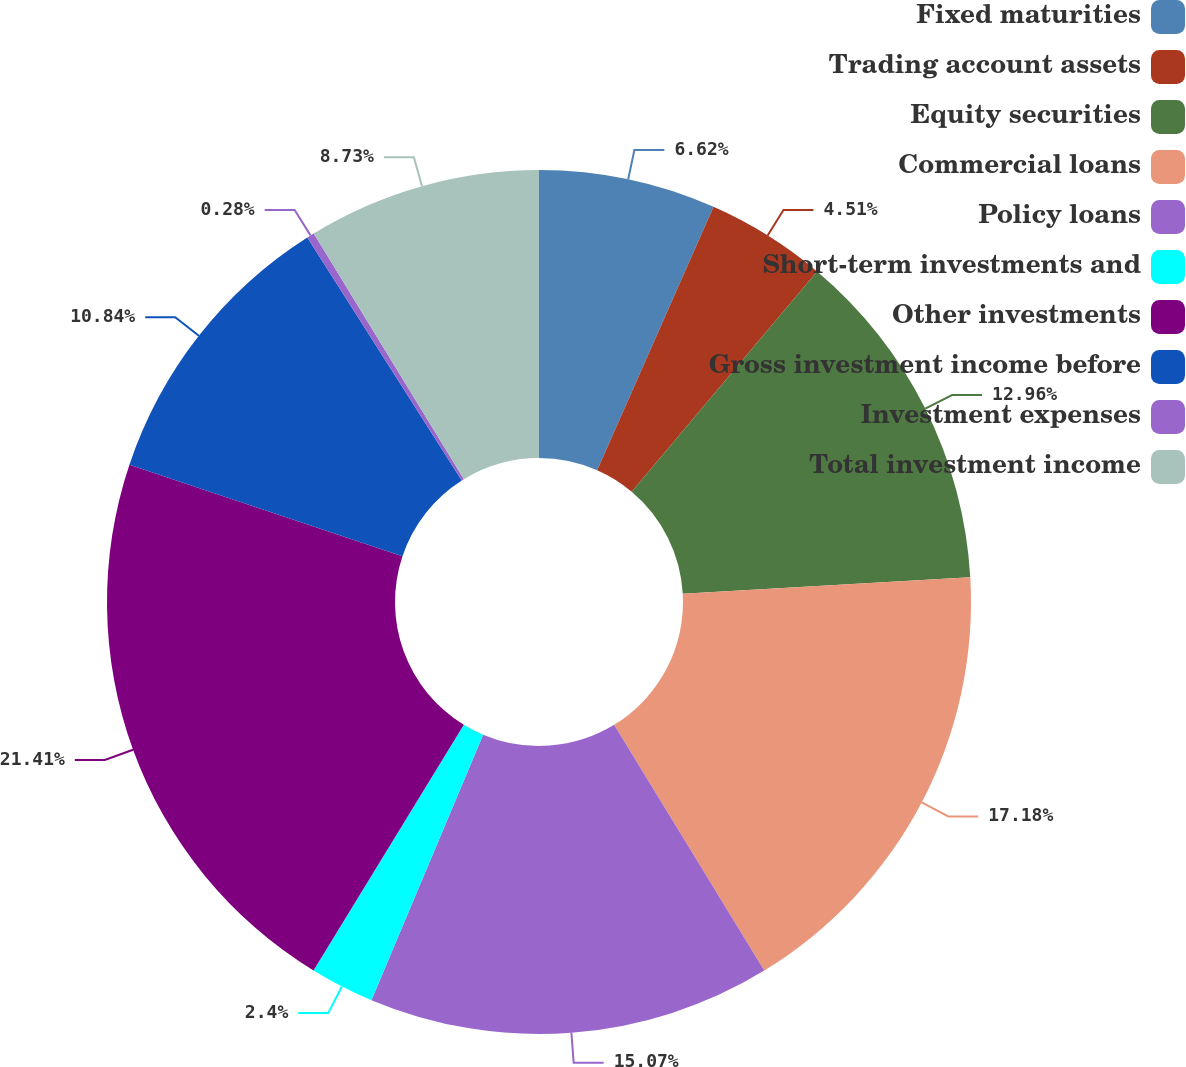<chart> <loc_0><loc_0><loc_500><loc_500><pie_chart><fcel>Fixed maturities<fcel>Trading account assets<fcel>Equity securities<fcel>Commercial loans<fcel>Policy loans<fcel>Short-term investments and<fcel>Other investments<fcel>Gross investment income before<fcel>Investment expenses<fcel>Total investment income<nl><fcel>6.62%<fcel>4.51%<fcel>12.96%<fcel>17.18%<fcel>15.07%<fcel>2.4%<fcel>21.41%<fcel>10.84%<fcel>0.28%<fcel>8.73%<nl></chart> 